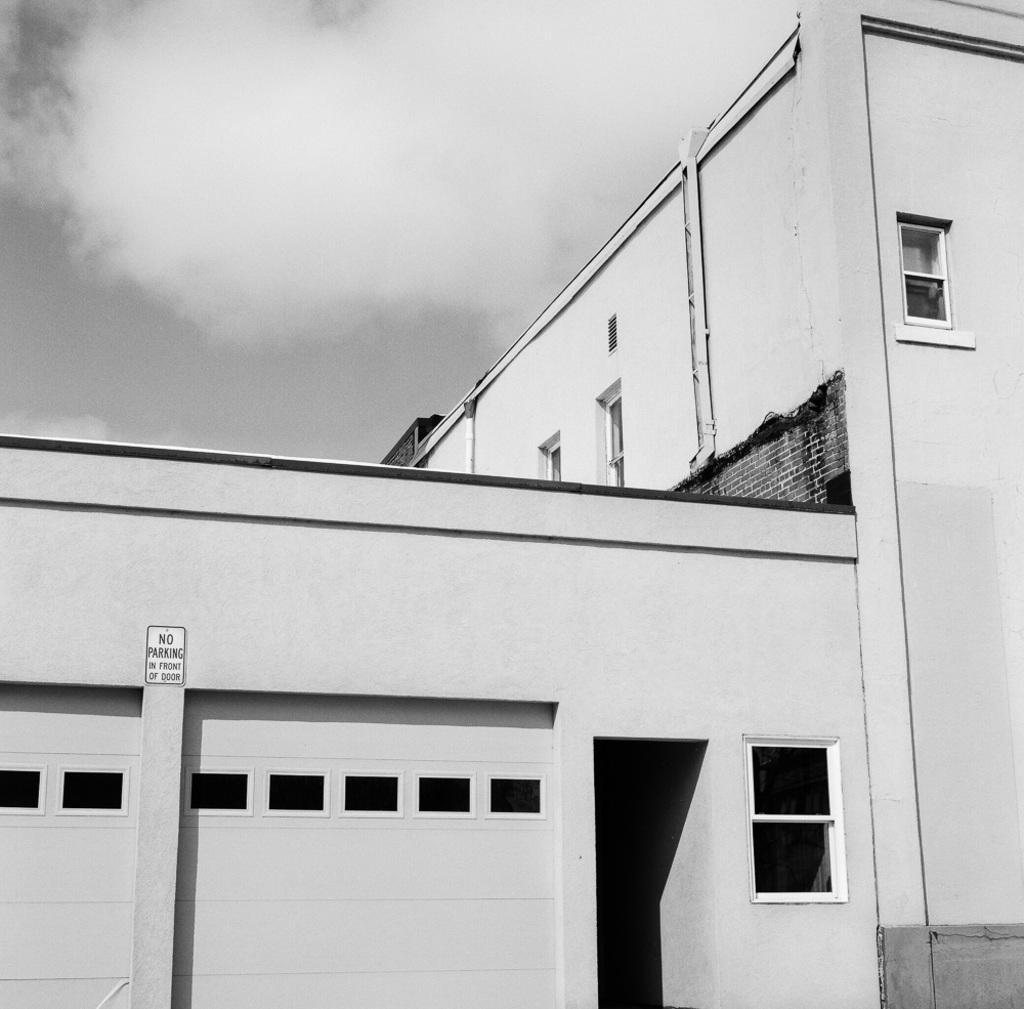In one or two sentences, can you explain what this image depicts? This is a black and white image. In this image we can see a building with windows. On the backside we can see the sky which looks cloudy. 